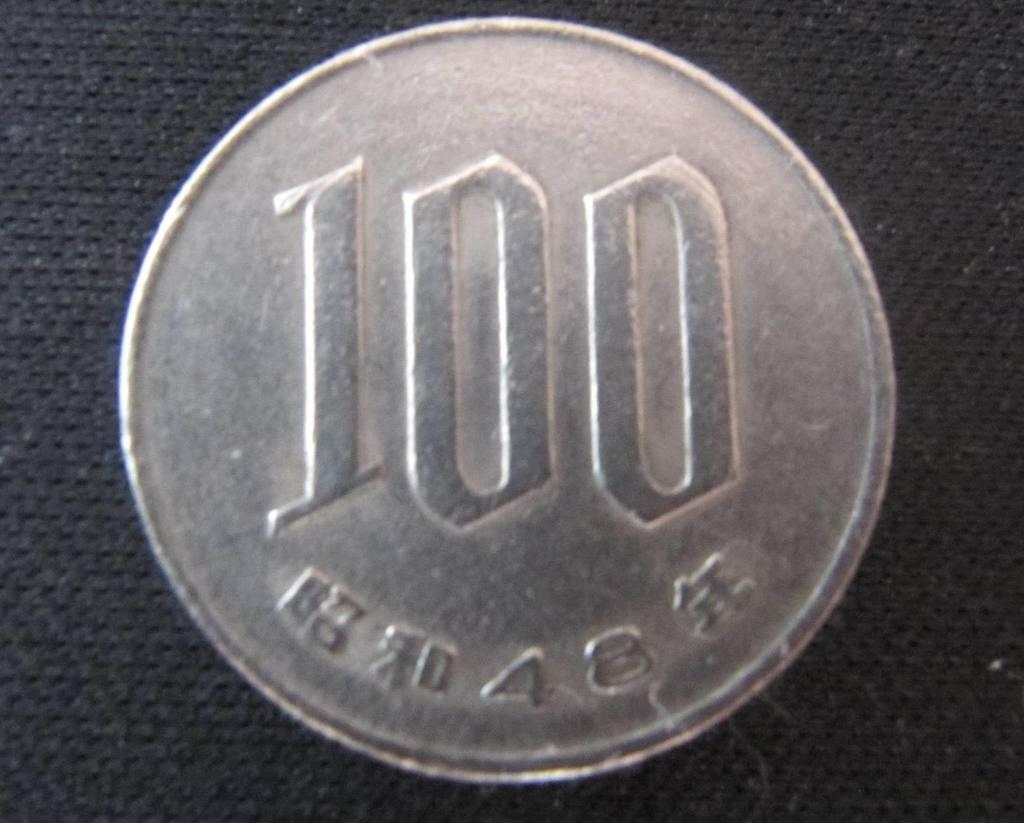<image>
Give a short and clear explanation of the subsequent image. Numbers 100 and 48 are etched onto the face of this coin. 